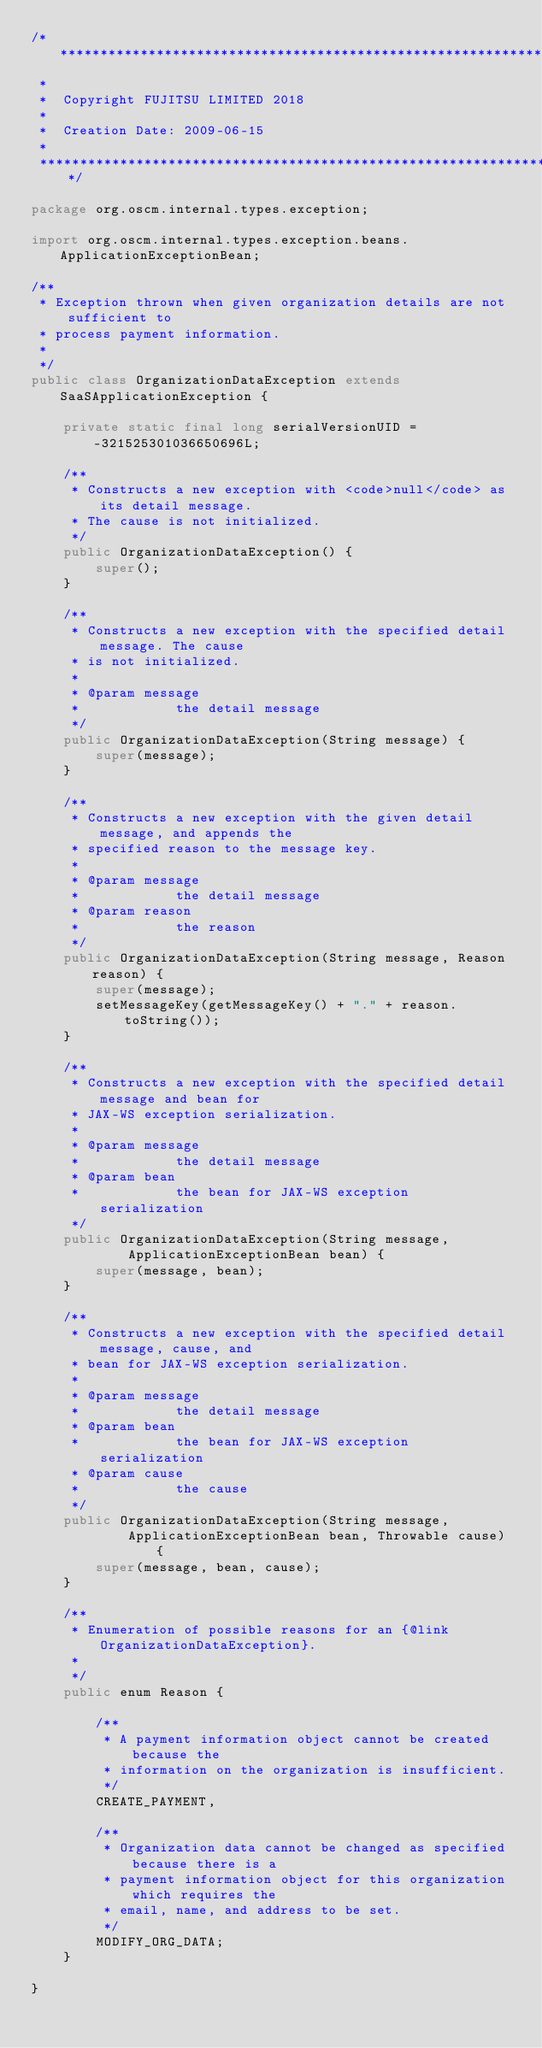Convert code to text. <code><loc_0><loc_0><loc_500><loc_500><_Java_>/*******************************************************************************
 *                                                                              
 *  Copyright FUJITSU LIMITED 2018
 *       
 *  Creation Date: 2009-06-15                                                      
 *                                                                              
 *******************************************************************************/

package org.oscm.internal.types.exception;

import org.oscm.internal.types.exception.beans.ApplicationExceptionBean;

/**
 * Exception thrown when given organization details are not sufficient to
 * process payment information.
 * 
 */
public class OrganizationDataException extends SaaSApplicationException {

    private static final long serialVersionUID = -321525301036650696L;

    /**
     * Constructs a new exception with <code>null</code> as its detail message.
     * The cause is not initialized.
     */
    public OrganizationDataException() {
        super();
    }

    /**
     * Constructs a new exception with the specified detail message. The cause
     * is not initialized.
     * 
     * @param message
     *            the detail message
     */
    public OrganizationDataException(String message) {
        super(message);
    }

    /**
     * Constructs a new exception with the given detail message, and appends the
     * specified reason to the message key.
     * 
     * @param message
     *            the detail message
     * @param reason
     *            the reason
     */
    public OrganizationDataException(String message, Reason reason) {
        super(message);
        setMessageKey(getMessageKey() + "." + reason.toString());
    }

    /**
     * Constructs a new exception with the specified detail message and bean for
     * JAX-WS exception serialization.
     * 
     * @param message
     *            the detail message
     * @param bean
     *            the bean for JAX-WS exception serialization
     */
    public OrganizationDataException(String message,
            ApplicationExceptionBean bean) {
        super(message, bean);
    }

    /**
     * Constructs a new exception with the specified detail message, cause, and
     * bean for JAX-WS exception serialization.
     * 
     * @param message
     *            the detail message
     * @param bean
     *            the bean for JAX-WS exception serialization
     * @param cause
     *            the cause
     */
    public OrganizationDataException(String message,
            ApplicationExceptionBean bean, Throwable cause) {
        super(message, bean, cause);
    }

    /**
     * Enumeration of possible reasons for an {@link OrganizationDataException}.
     * 
     */
    public enum Reason {

        /**
         * A payment information object cannot be created because the
         * information on the organization is insufficient.
         */
        CREATE_PAYMENT,

        /**
         * Organization data cannot be changed as specified because there is a
         * payment information object for this organization which requires the
         * email, name, and address to be set.
         */
        MODIFY_ORG_DATA;
    }

}
</code> 